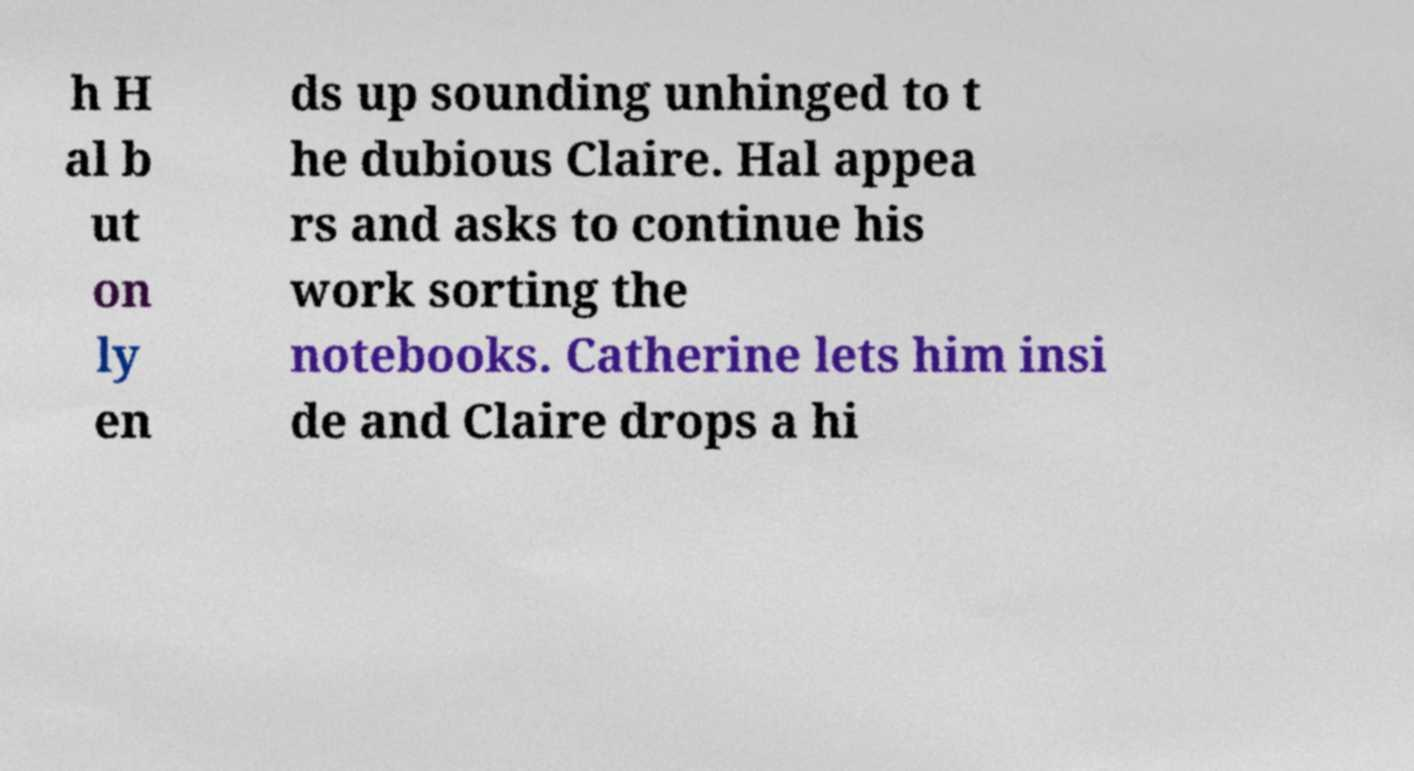For documentation purposes, I need the text within this image transcribed. Could you provide that? h H al b ut on ly en ds up sounding unhinged to t he dubious Claire. Hal appea rs and asks to continue his work sorting the notebooks. Catherine lets him insi de and Claire drops a hi 